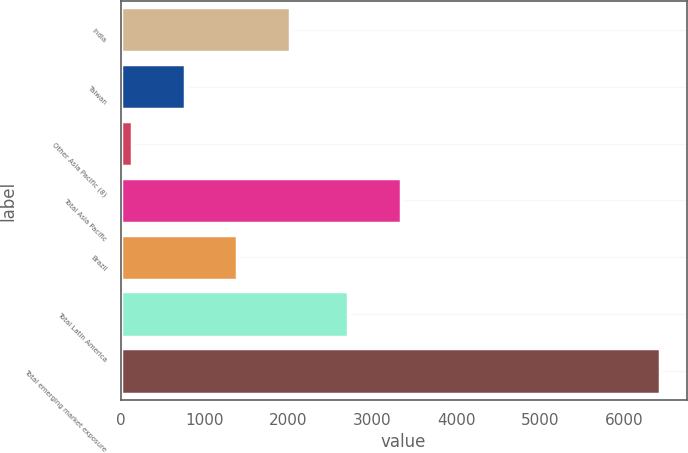Convert chart. <chart><loc_0><loc_0><loc_500><loc_500><bar_chart><fcel>India<fcel>Taiwan<fcel>Other Asia Pacific (8)<fcel>Total Asia Pacific<fcel>Brazil<fcel>Total Latin America<fcel>Total emerging market exposure<nl><fcel>2021.2<fcel>762.4<fcel>133<fcel>3341.4<fcel>1391.8<fcel>2712<fcel>6427<nl></chart> 